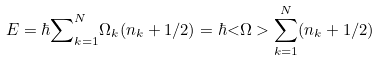<formula> <loc_0><loc_0><loc_500><loc_500>E = \hbar { \sum } _ { k = 1 } ^ { N } \Omega _ { k } ( n _ { k } + 1 / 2 ) = \hbar { < } \Omega > \sum _ { k = 1 } ^ { N } ( n _ { k } + 1 / 2 )</formula> 